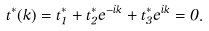<formula> <loc_0><loc_0><loc_500><loc_500>t ^ { \ast } ( k ) = t _ { 1 } ^ { \ast } + t _ { 2 } ^ { \ast } e ^ { - i k } + t _ { 3 } ^ { \ast } e ^ { i k } = 0 .</formula> 